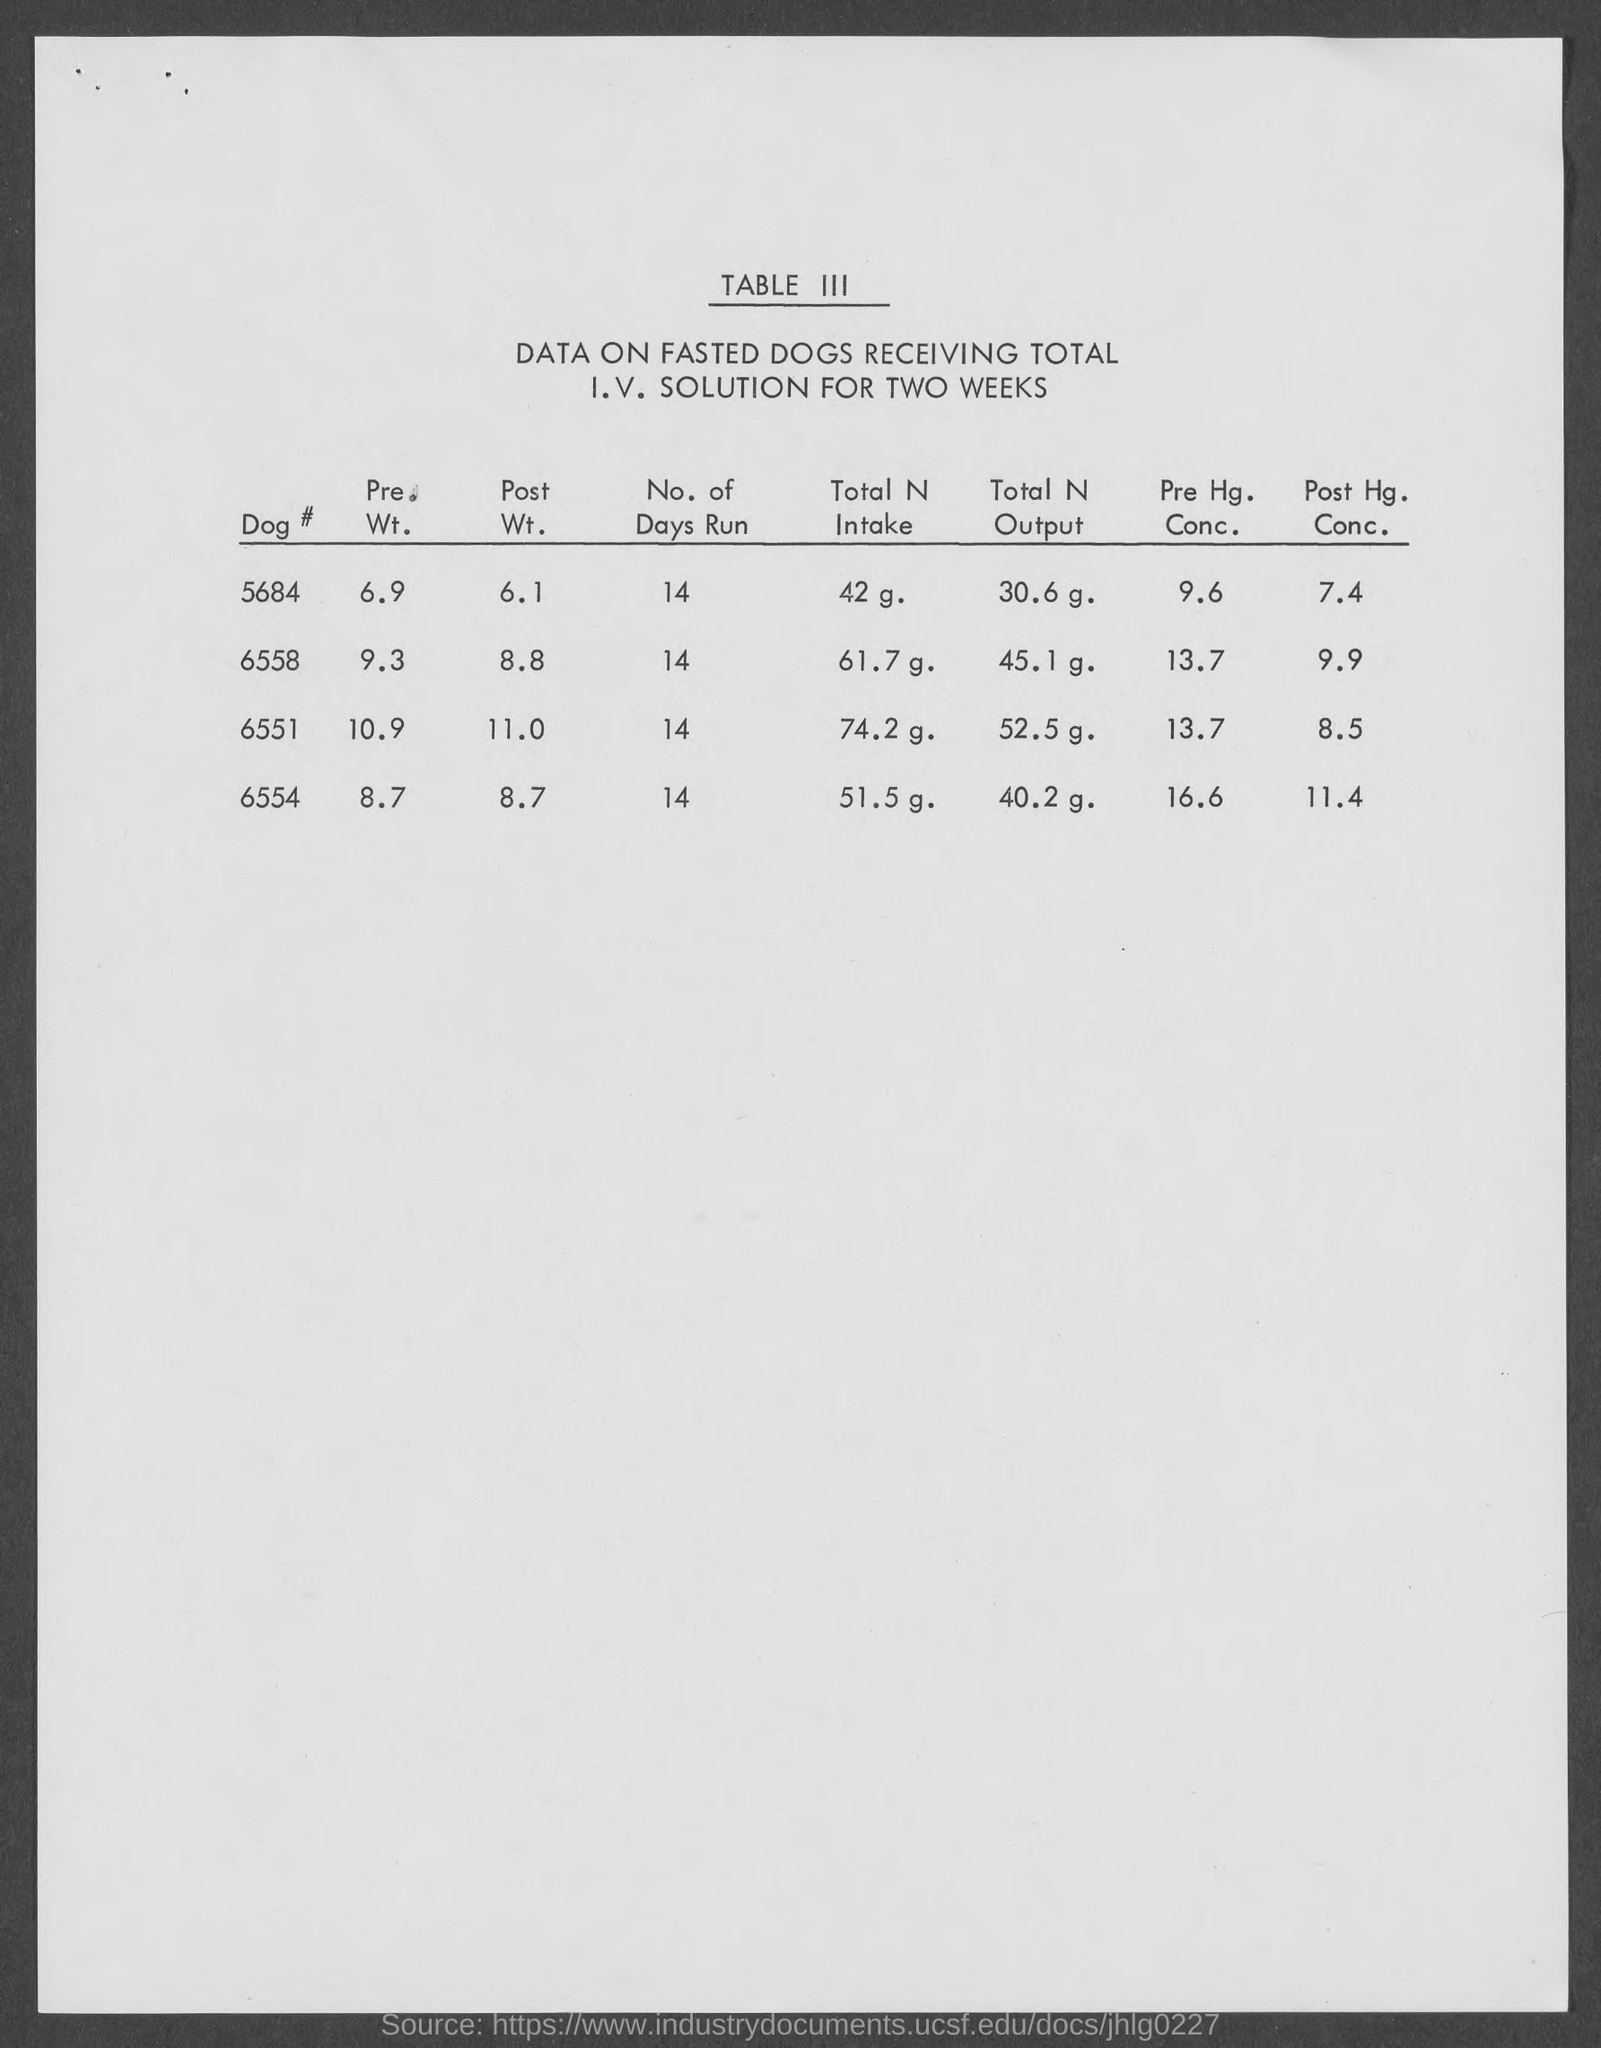What is the total n intake of dog # 5684 ?
Provide a short and direct response. 42 g. What is the post hg. conc. of dog# 6554
Offer a terse response. 11.4. What is the no.of days run for dog# 5684
Offer a terse response. 14. What is the total n output for dog # 6558
Offer a terse response. 45.1 g. What is the pre. wt. of dog # 6558
Your answer should be compact. 9.3. What is the table number mentioned ?
Your answer should be very brief. III. What is the post hg. conc.of dog# 6558?
Your response must be concise. 9.9. What is the pre. wt. of dog# 6554
Provide a short and direct response. 8.7. What is the pre. wt. of dog# 6551
Give a very brief answer. 10.9. 